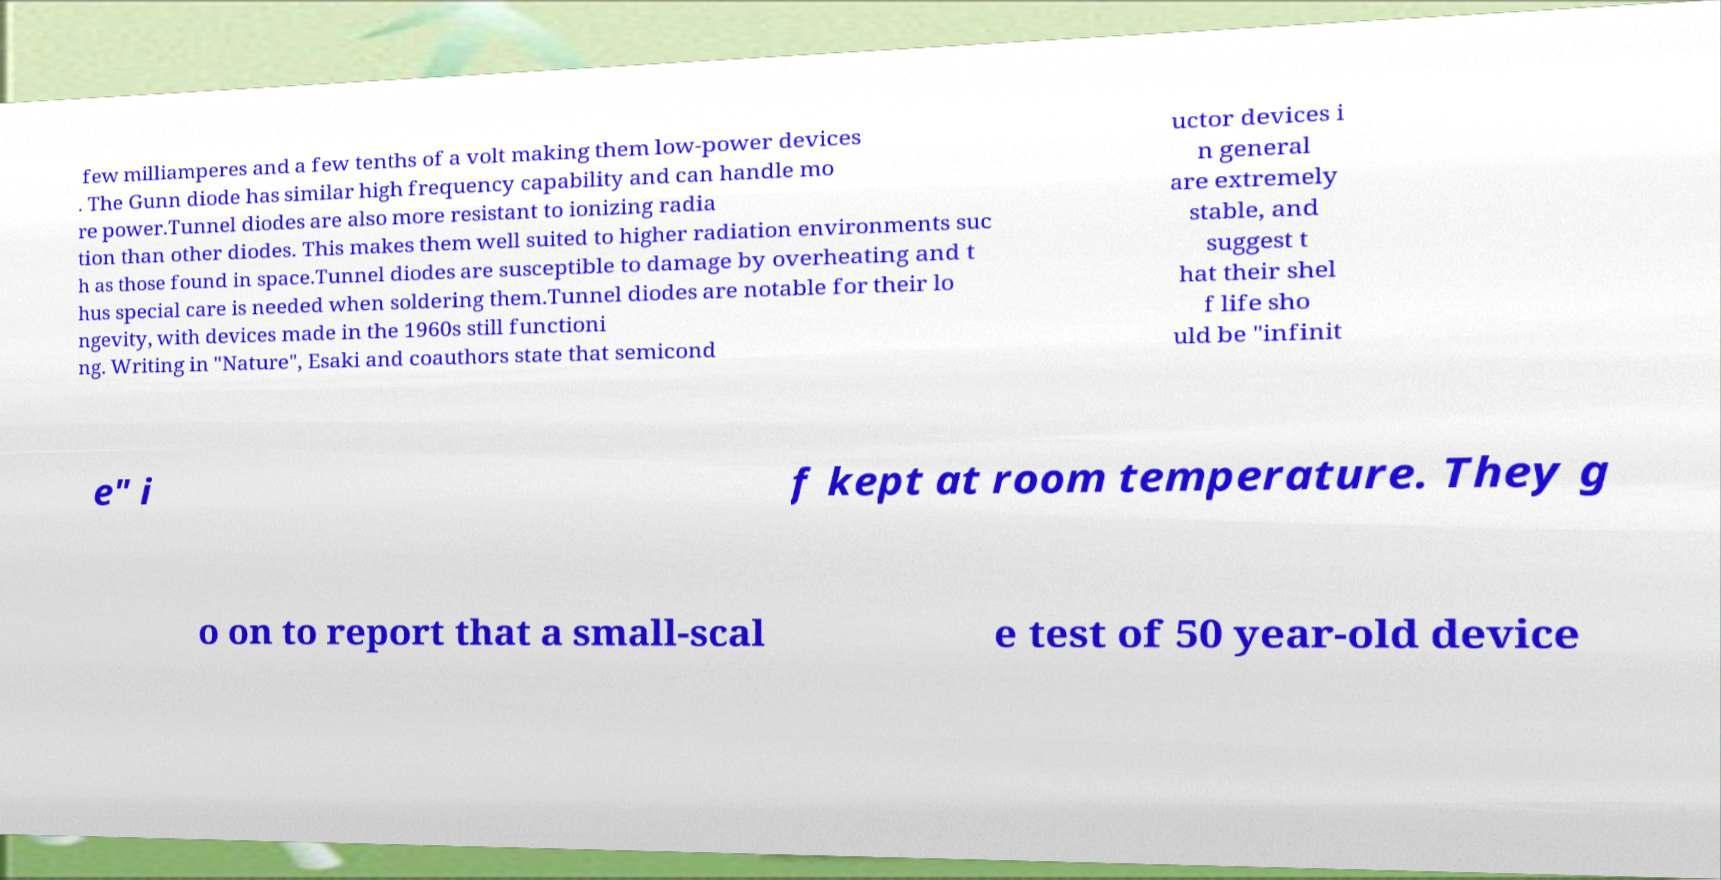Could you assist in decoding the text presented in this image and type it out clearly? few milliamperes and a few tenths of a volt making them low-power devices . The Gunn diode has similar high frequency capability and can handle mo re power.Tunnel diodes are also more resistant to ionizing radia tion than other diodes. This makes them well suited to higher radiation environments suc h as those found in space.Tunnel diodes are susceptible to damage by overheating and t hus special care is needed when soldering them.Tunnel diodes are notable for their lo ngevity, with devices made in the 1960s still functioni ng. Writing in "Nature", Esaki and coauthors state that semicond uctor devices i n general are extremely stable, and suggest t hat their shel f life sho uld be "infinit e" i f kept at room temperature. They g o on to report that a small-scal e test of 50 year-old device 